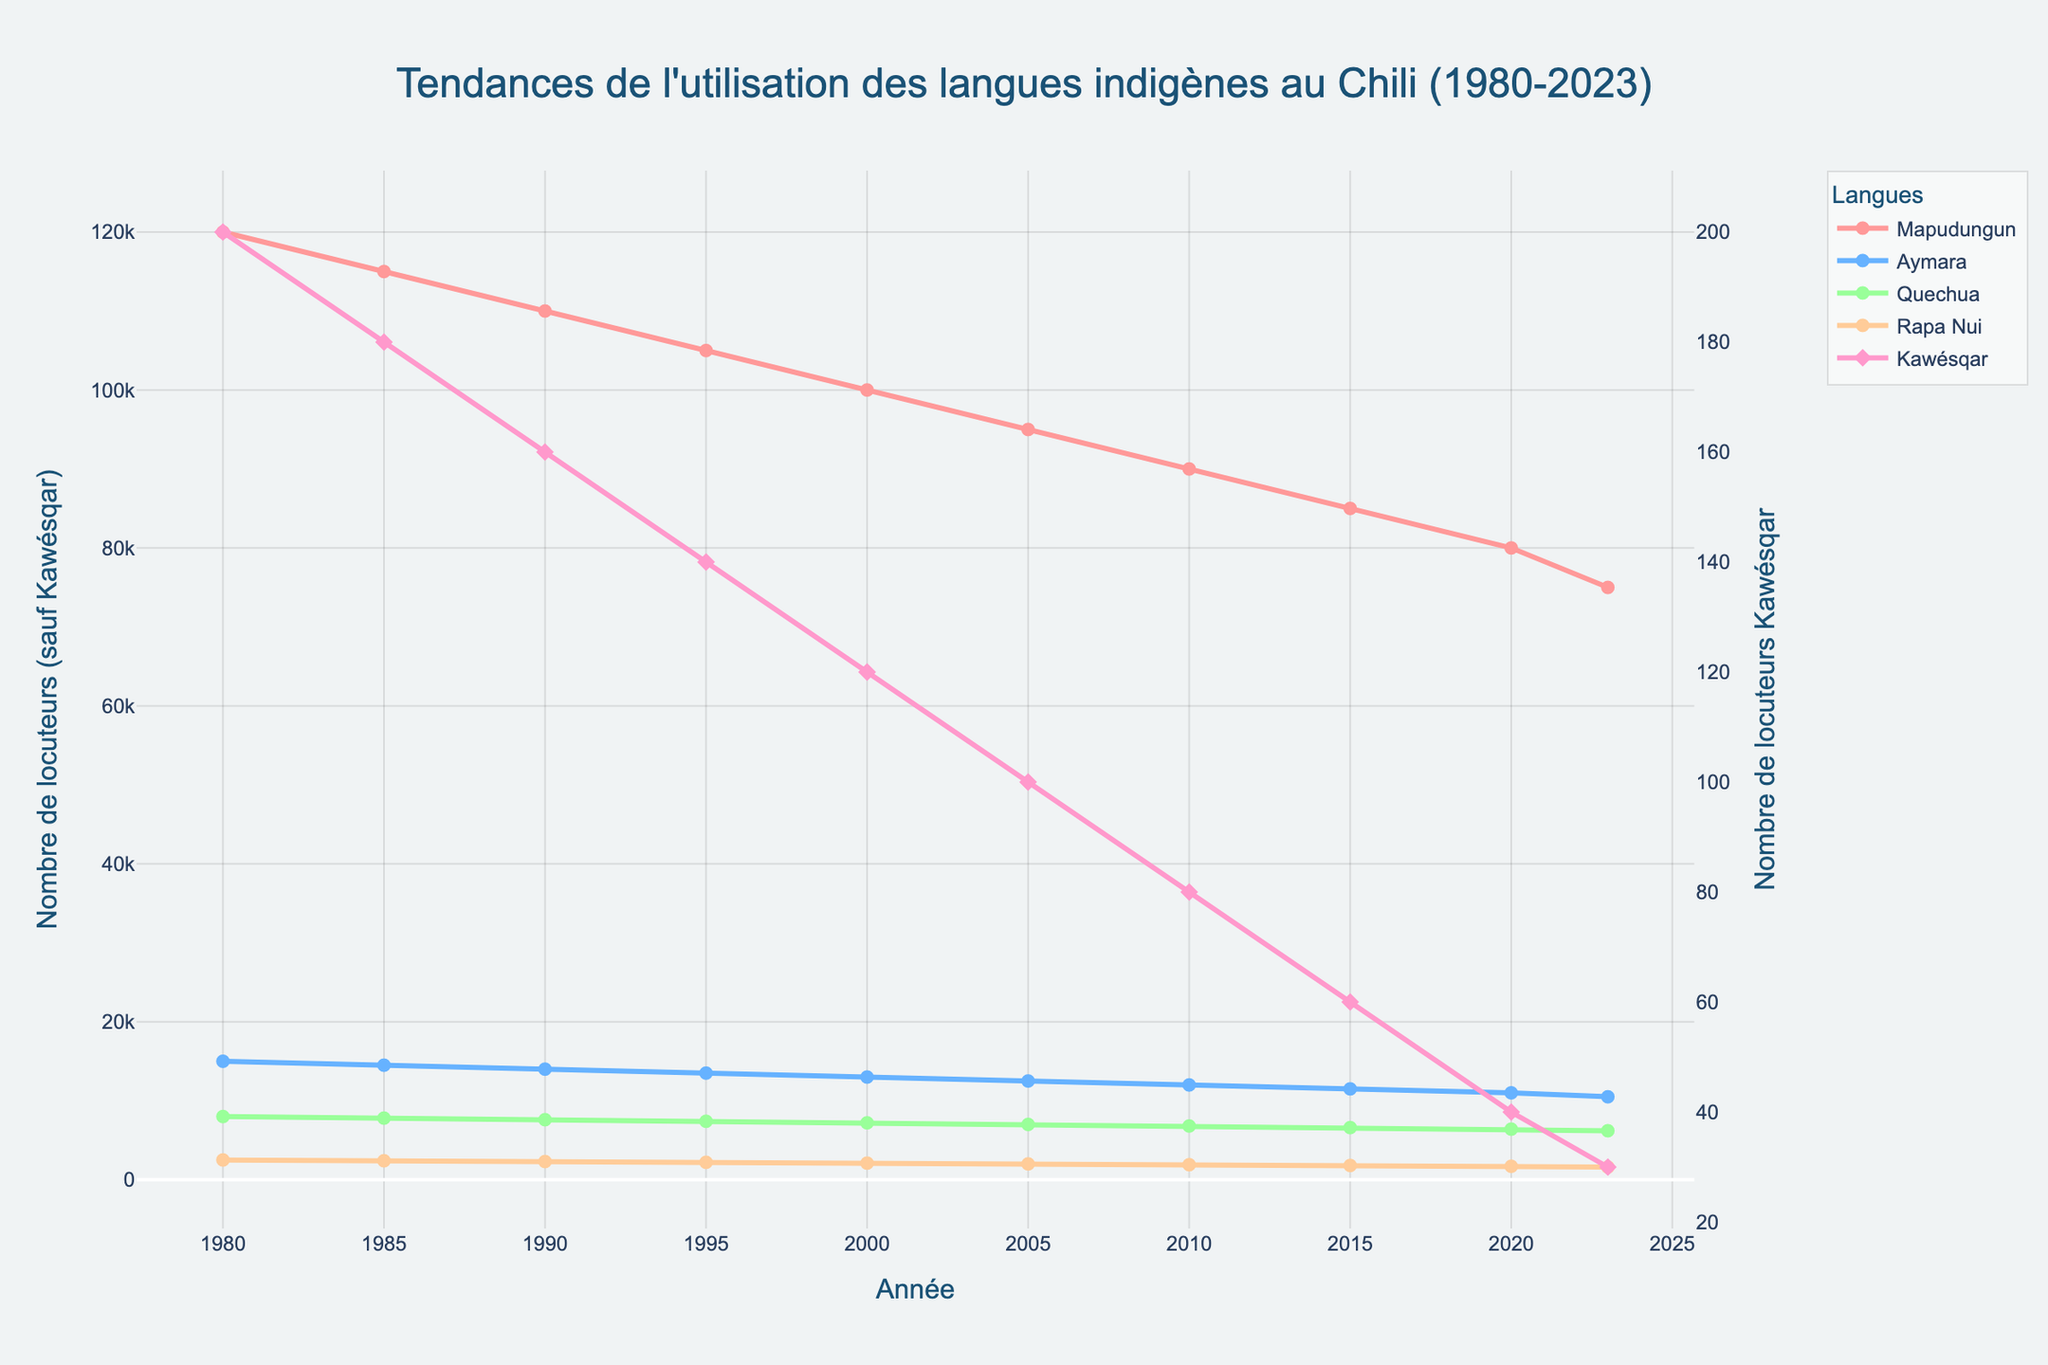What is the trend of Mapudungun language usage from 1980 to 2023? The number of Mapudungun speakers shows a declining trend over the years. Starting from 120,000 in 1980 and decreasing to 75,000 in 2023.
Answer: Declining Which indigenous language had the least number of speakers in 2023? By observing the figure, we see that Kawésqar had the least number of speakers in 2023, with only 30 speakers.
Answer: Kawésqar How many more speakers did Mapudungun have compared to Aymara in the year 2000? In 2000, Mapudungun had 100,000 speakers, and Aymara had 13,000 speakers. The difference is 100,000 - 13,000 = 87,000.
Answer: 87,000 What is the color used to represent the Aymara language in the figure? The Aymara language is represented in blue.
Answer: Blue Compare the rate of decline in speakers of Quechua and Rapa Nui from 1980 to 2023. Which language experienced a faster decline? Quechua speakers decreased from 8,000 to 6,200 (1,800) while Rapa Nui speakers decreased from 2,500 to 1,600 (900). The rate of decline per year is faster for Quechua.
Answer: Quechua Calculate the average number of Rapa Nui speakers across all years. Sum all values of Rapa Nui speakers (2500 + 2400 + 2300 + 2200 + 2100 + 2000 + 1900 + 1800 + 1700 + 1600 = 19500). There are 10 data points, so the average is 19500 / 10 = 1,950.
Answer: 1,950 What is the general trend of Kawésqar language speakers? The Kawésqar language shows a continuous decline from 200 speakers in 1980 to only 30 speakers in 2023.
Answer: Declining Which year had the highest number of Mapudungun speakers, and how many were there? 1980 had the highest number of Mapudungun speakers with 120,000 speakers.
Answer: 1980, 120,000 Compare the number of Aymara speakers in 1980 and 2023. Has it increased or decreased, and by how much? In 1980, there were 15,000 Aymara speakers, and in 2023, there were 10,500. The decrease is 15,000 - 10,500 = 4,500.
Answer: Decreased, 4,500 What are the titles of the y-axes in the plot? The primary y-axis is titled "Nombre de locuteurs (sauf Kawésqar)" and the secondary y-axis is titled "Nombre de locuteurs Kawésqar".
Answer: Nombre de locuteurs (sauf Kawésqar), Nombre de locuteurs Kawésqar 